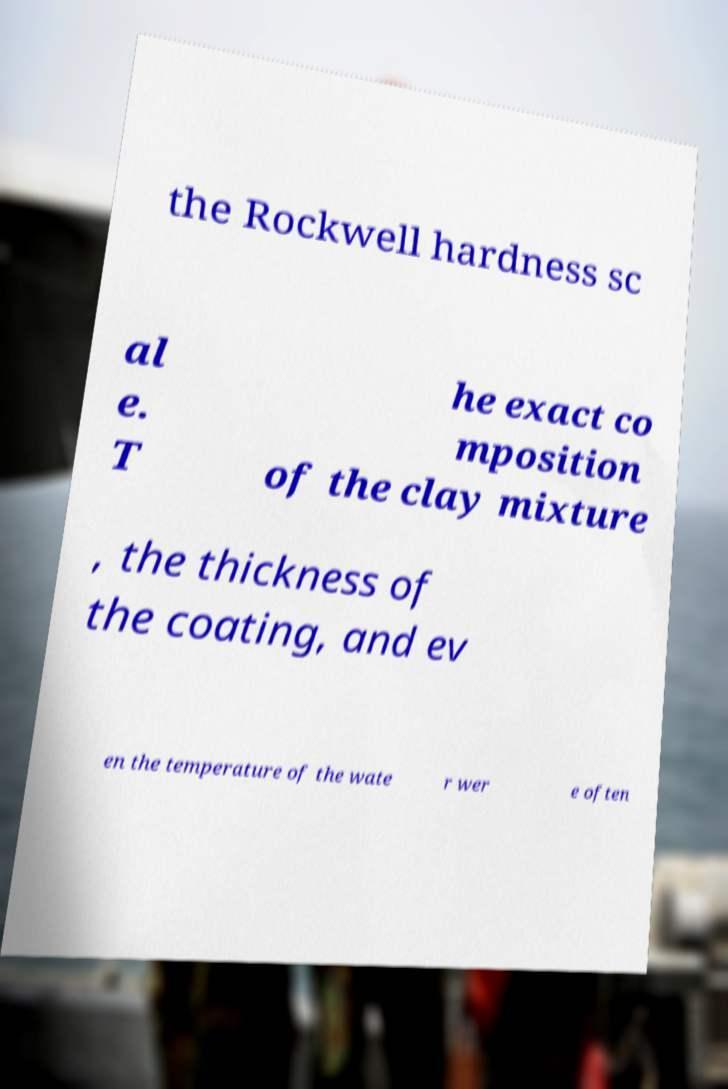Please read and relay the text visible in this image. What does it say? the Rockwell hardness sc al e. T he exact co mposition of the clay mixture , the thickness of the coating, and ev en the temperature of the wate r wer e often 